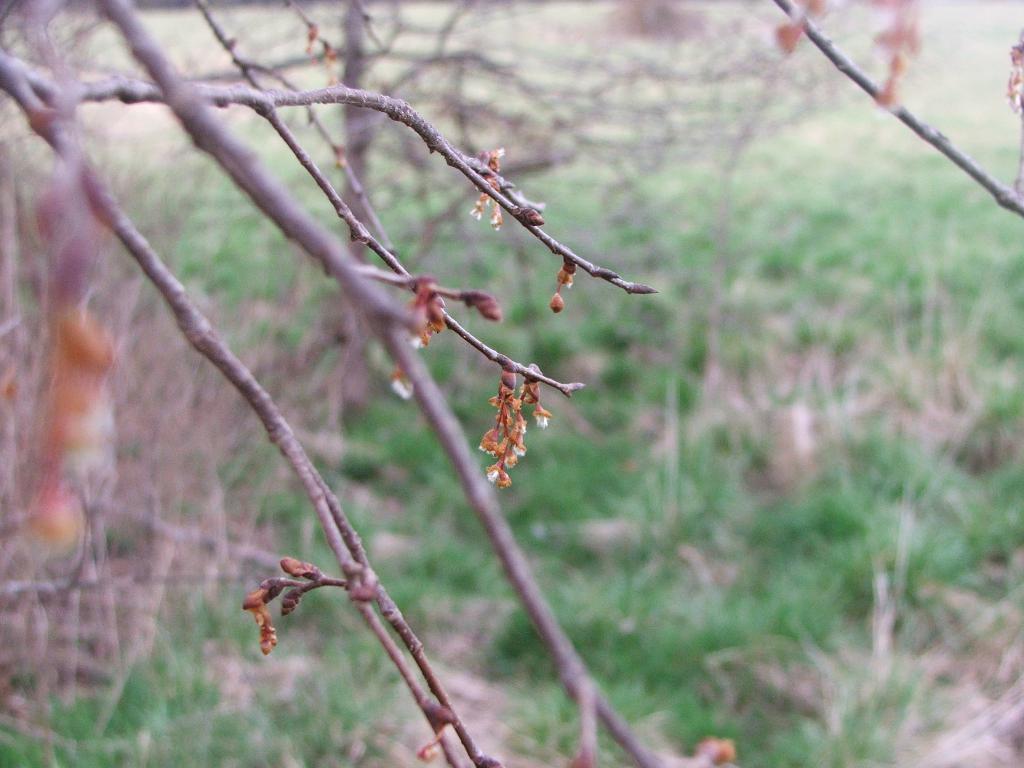Can you describe this image briefly? In this image we can see some trees and grass, also we can see some flowers on the branches of the trees. 